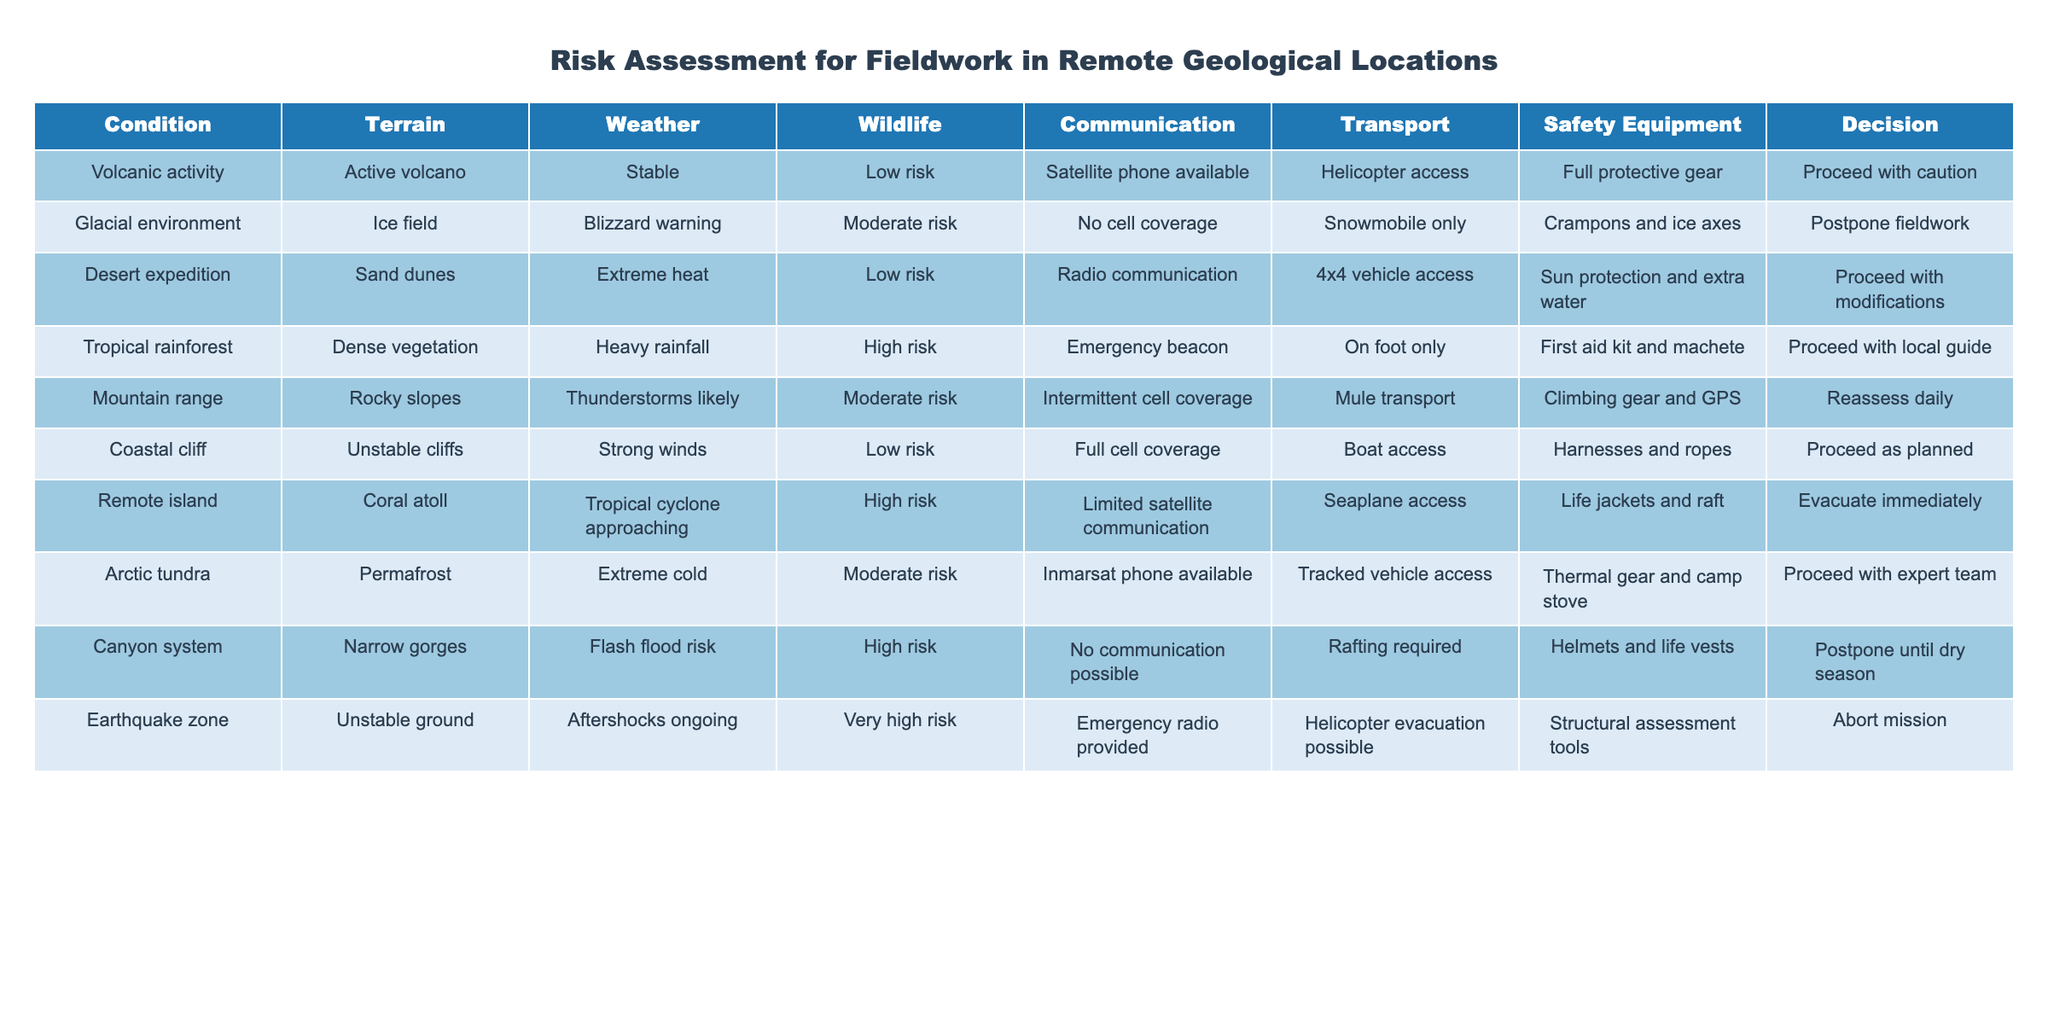What is the decision for an active volcano with stable weather? The row for volcanic activity shows that for an active volcano with stable weather, the decision is to proceed with caution, highlighting a careful approach despite the stability.
Answer: Proceed with caution Which location has the highest risk associated with wildlife? The tropical rainforest has a high risk associated with wildlife as indicated in the table, making it the only location categorized with high risk in that column.
Answer: Tropical rainforest In how many scenarios is communication available? There are six rows where communication is listed as available (Satellite phone, Radio communication, Full cell coverage, Inmarsat phone, Emergency beacon, and Limited satellite communication). Thus, the answer is the count of these scenarios.
Answer: 6 What is the safety equipment required for a canyon system during a flash flood risk? The table entry for the canyon system indicates that the required safety equipment is helmets and life vests, specifically mentioned in the second to last column.
Answer: Helmets and life vests Is it true that the decision for the Arctic tundra involves proceeding with an expert team? The row for the Arctic tundra specifies that the decision involves proceeding with an expert team, which indicates that the statement is accurate based on the table data.
Answer: True What types of transport are available in the volcanic activity scenario? In the volcanic activity row, the transportation options specified are helicopter access, thus confirming that this is the only listed method in that scenario.
Answer: Helicopter access What is the average risk level across all scenarios listed in the table? The risk levels range from low to very high with corresponding numeric values: Low=1, Moderate=2, High=3, Very High=4. The levels can be translated as follows: 1 (Low) in 5 scenarios, 2 (Moderate) in 3 scenarios, 3 (High) in 3 scenarios, and 4 (Very High) in 1 scenario, resulting in an average risk of (1*5 + 2*3 + 3*3 + 4*1) / 12 = 1.83.
Answer: 1.83 Which geological location is recommended to evacuate immediately? The remote island scenario indicates that with a tropical cyclone approaching, the decision is to evacuate immediately as highlighted in the decision column.
Answer: Remote island How many scenarios involve postponing fieldwork? The table indicates that fieldwork is to be postponed in three scenarios: glacial environment, canyon system, and earthquake zone. Thus, the answer involves counting these categories.
Answer: 3 